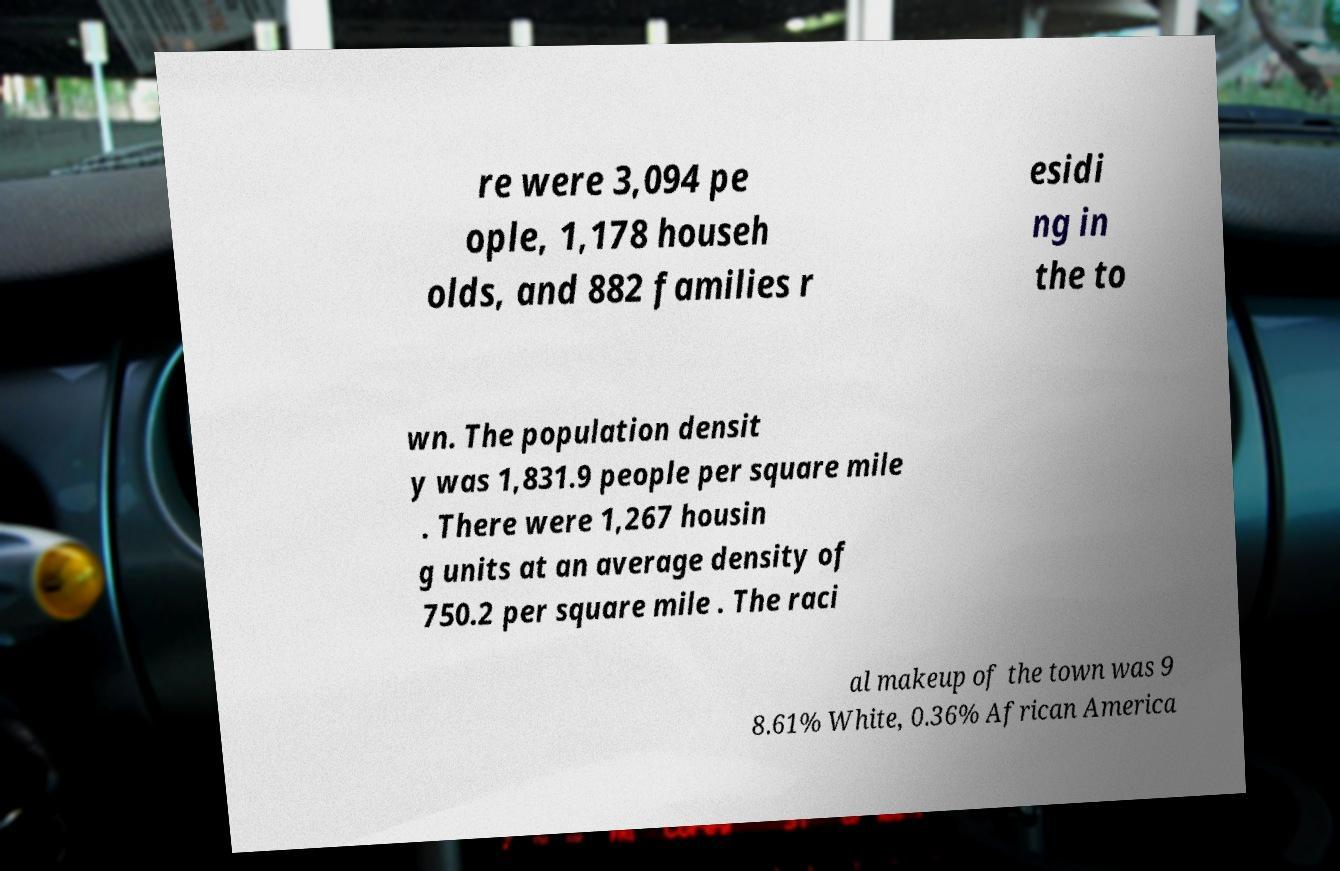Can you read and provide the text displayed in the image?This photo seems to have some interesting text. Can you extract and type it out for me? re were 3,094 pe ople, 1,178 househ olds, and 882 families r esidi ng in the to wn. The population densit y was 1,831.9 people per square mile . There were 1,267 housin g units at an average density of 750.2 per square mile . The raci al makeup of the town was 9 8.61% White, 0.36% African America 